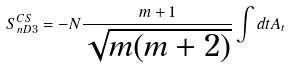Convert formula to latex. <formula><loc_0><loc_0><loc_500><loc_500>S _ { n D 3 } ^ { C S } = - N \frac { m + 1 } { \sqrt { m ( m + 2 ) } } \int d t A _ { t }</formula> 